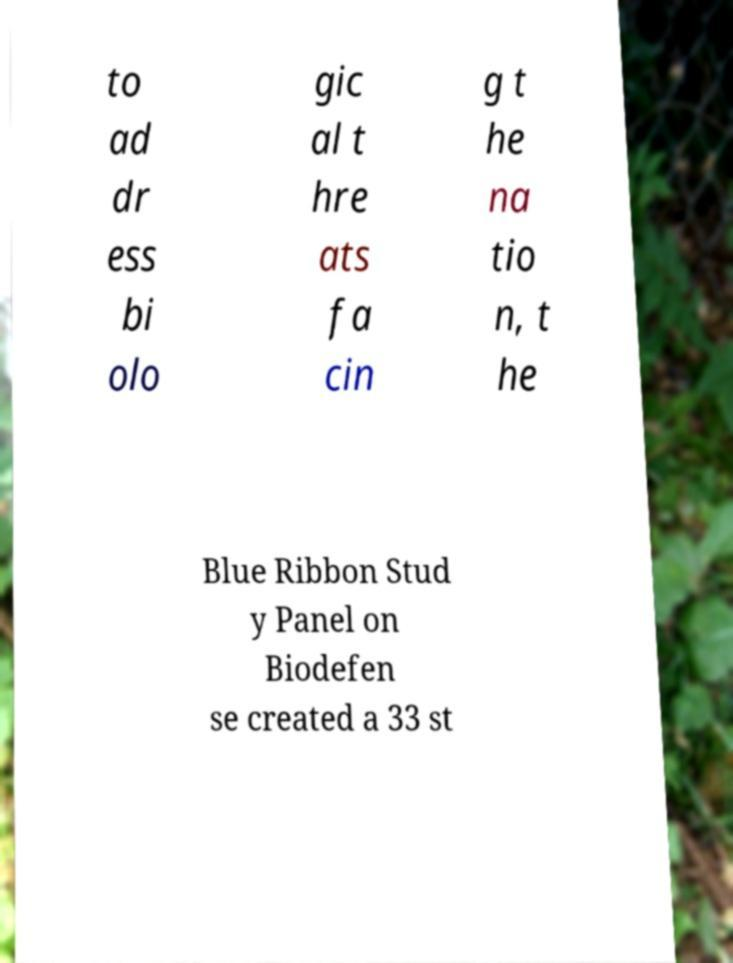Could you assist in decoding the text presented in this image and type it out clearly? to ad dr ess bi olo gic al t hre ats fa cin g t he na tio n, t he Blue Ribbon Stud y Panel on Biodefen se created a 33 st 